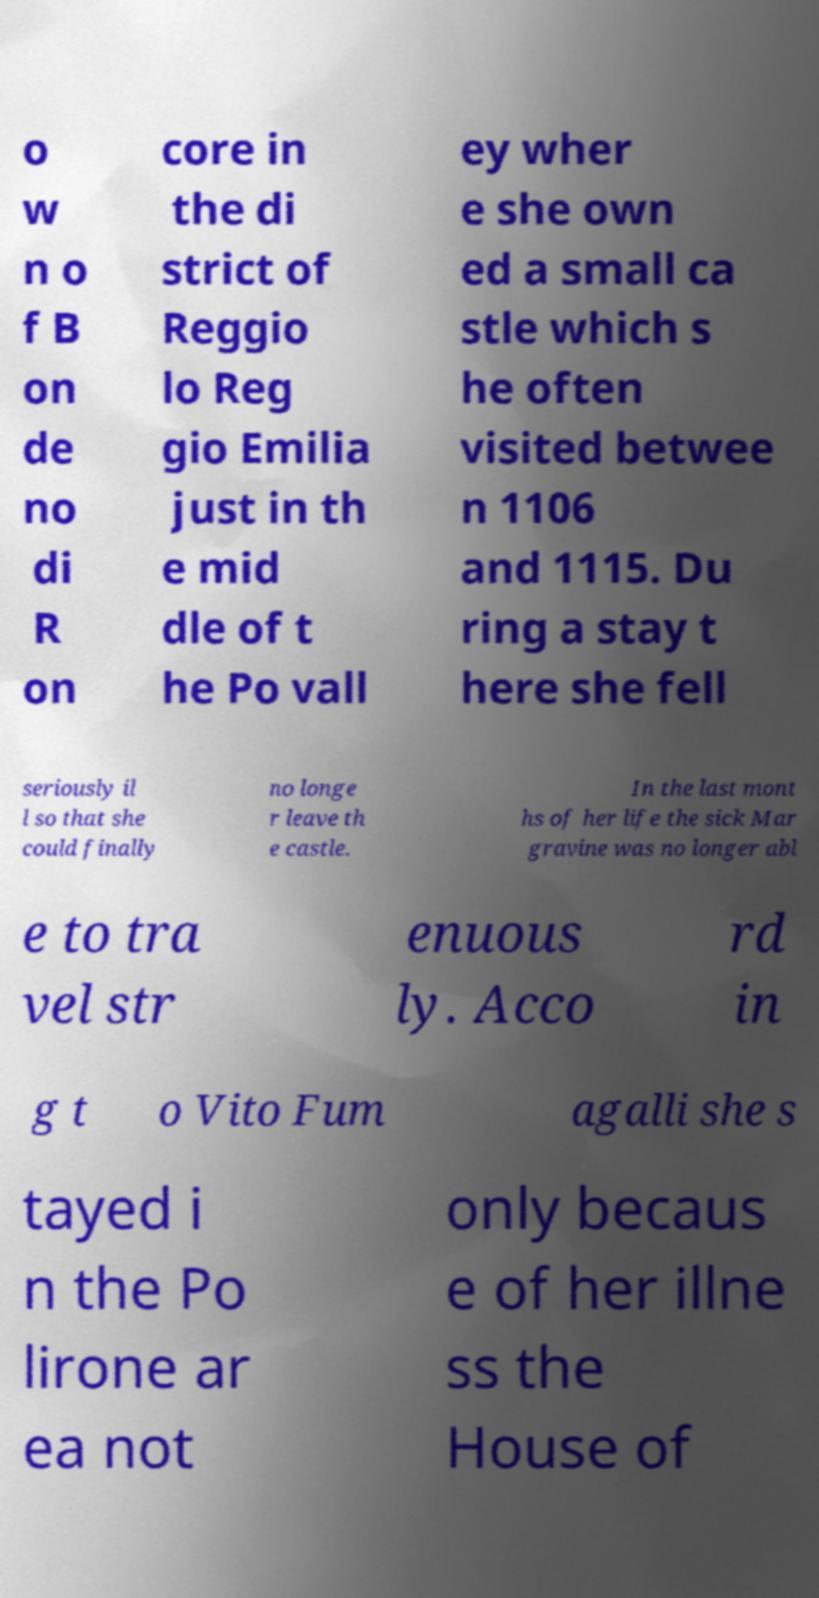Please identify and transcribe the text found in this image. o w n o f B on de no di R on core in the di strict of Reggio lo Reg gio Emilia just in th e mid dle of t he Po vall ey wher e she own ed a small ca stle which s he often visited betwee n 1106 and 1115. Du ring a stay t here she fell seriously il l so that she could finally no longe r leave th e castle. In the last mont hs of her life the sick Mar gravine was no longer abl e to tra vel str enuous ly. Acco rd in g t o Vito Fum agalli she s tayed i n the Po lirone ar ea not only becaus e of her illne ss the House of 